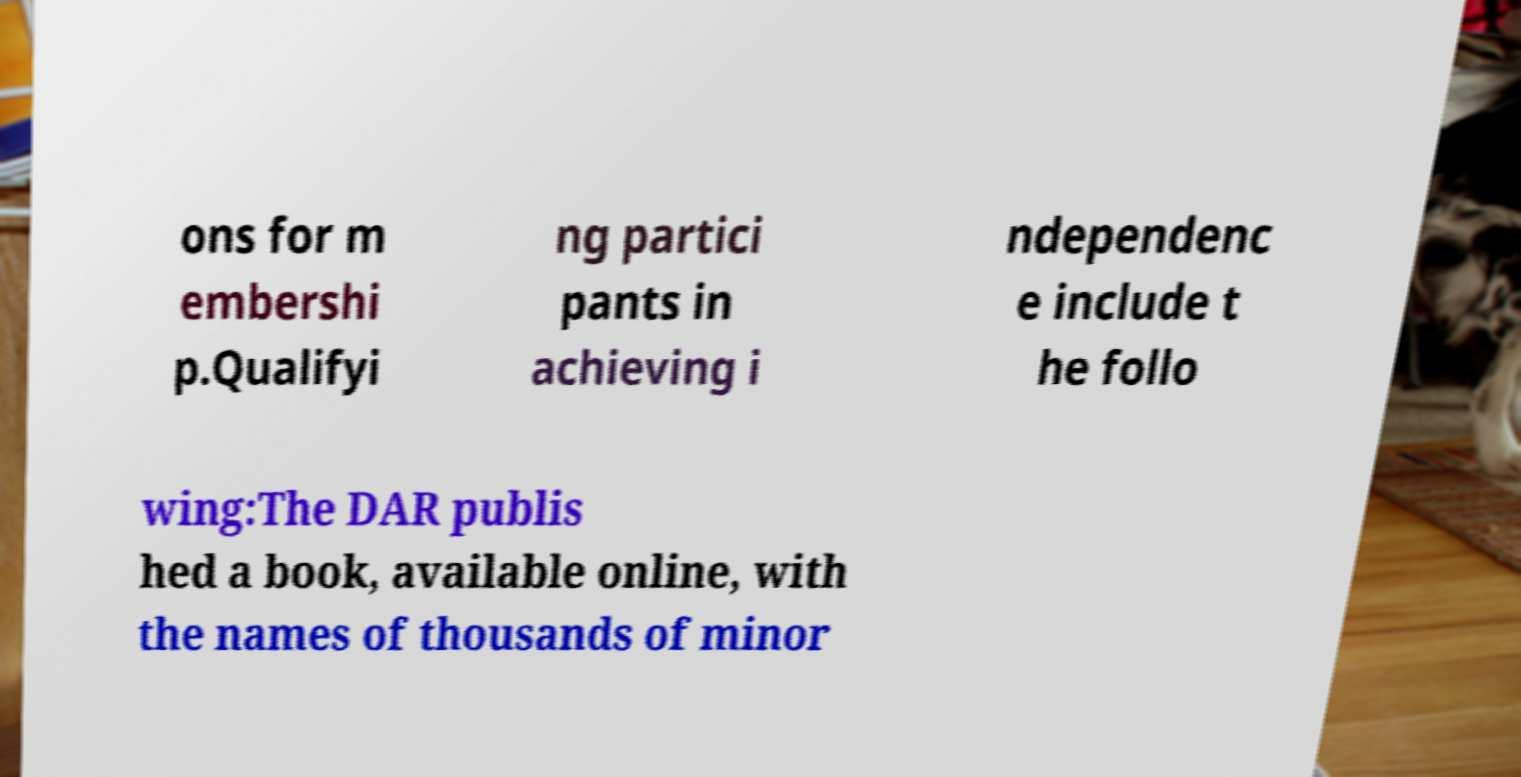Please read and relay the text visible in this image. What does it say? ons for m embershi p.Qualifyi ng partici pants in achieving i ndependenc e include t he follo wing:The DAR publis hed a book, available online, with the names of thousands of minor 